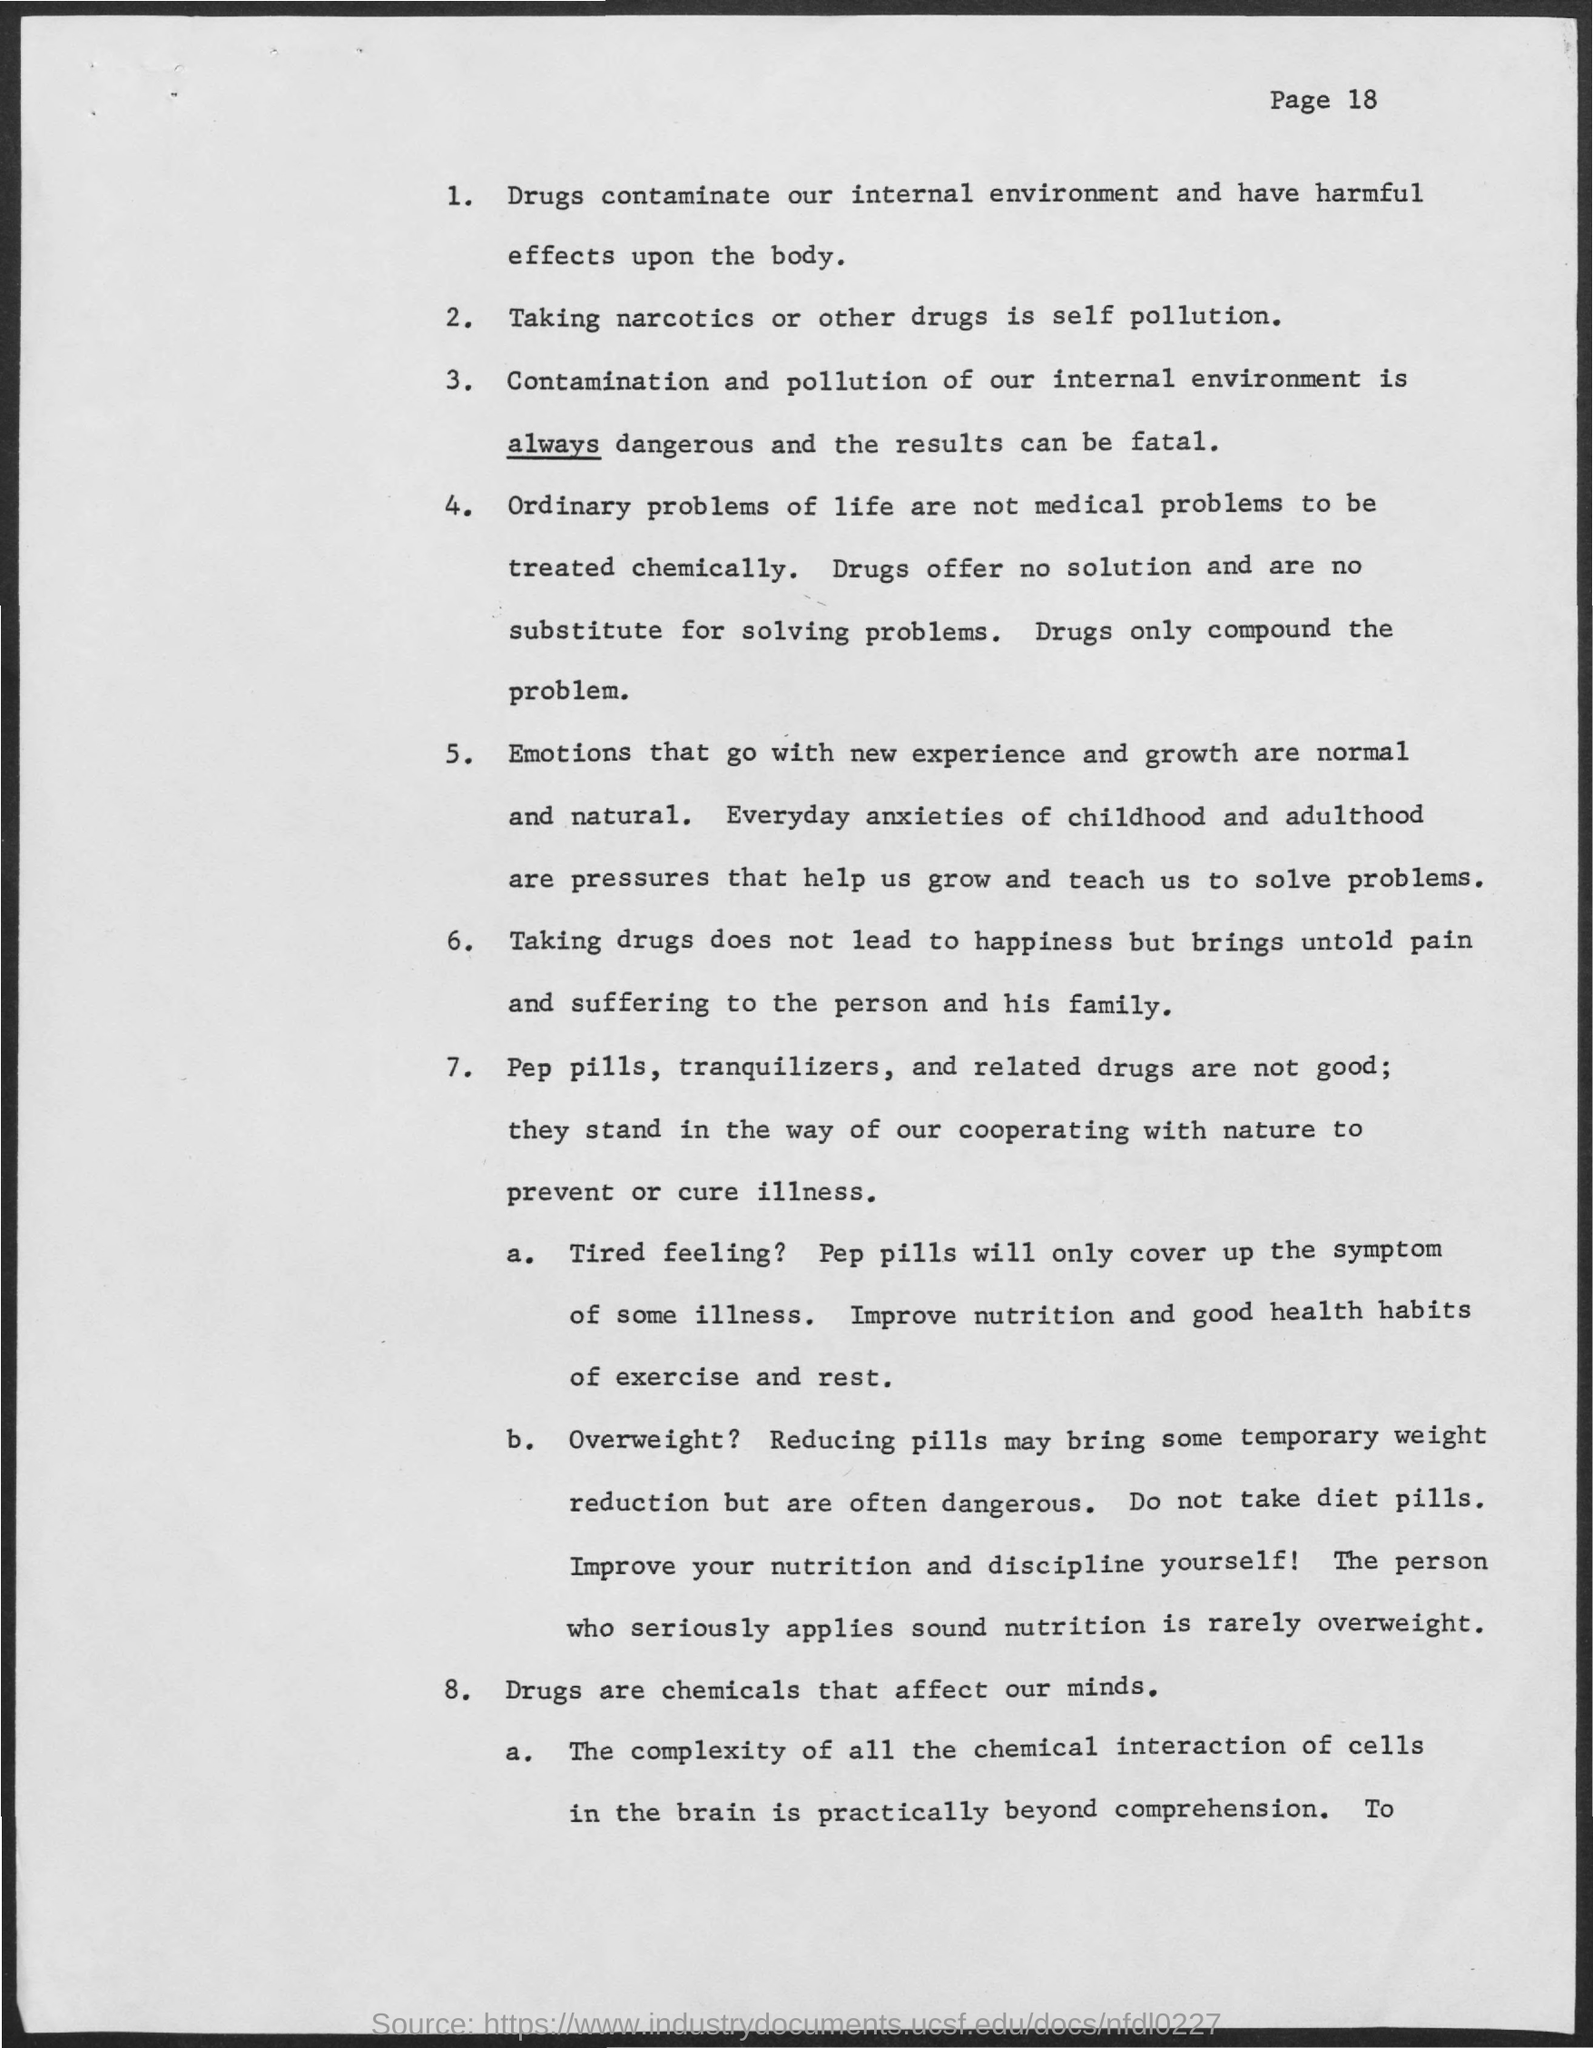Outline some significant characteristics in this image. The page number is 18, as declared. Taking narcotics or other drugs is considered self-pollution. 